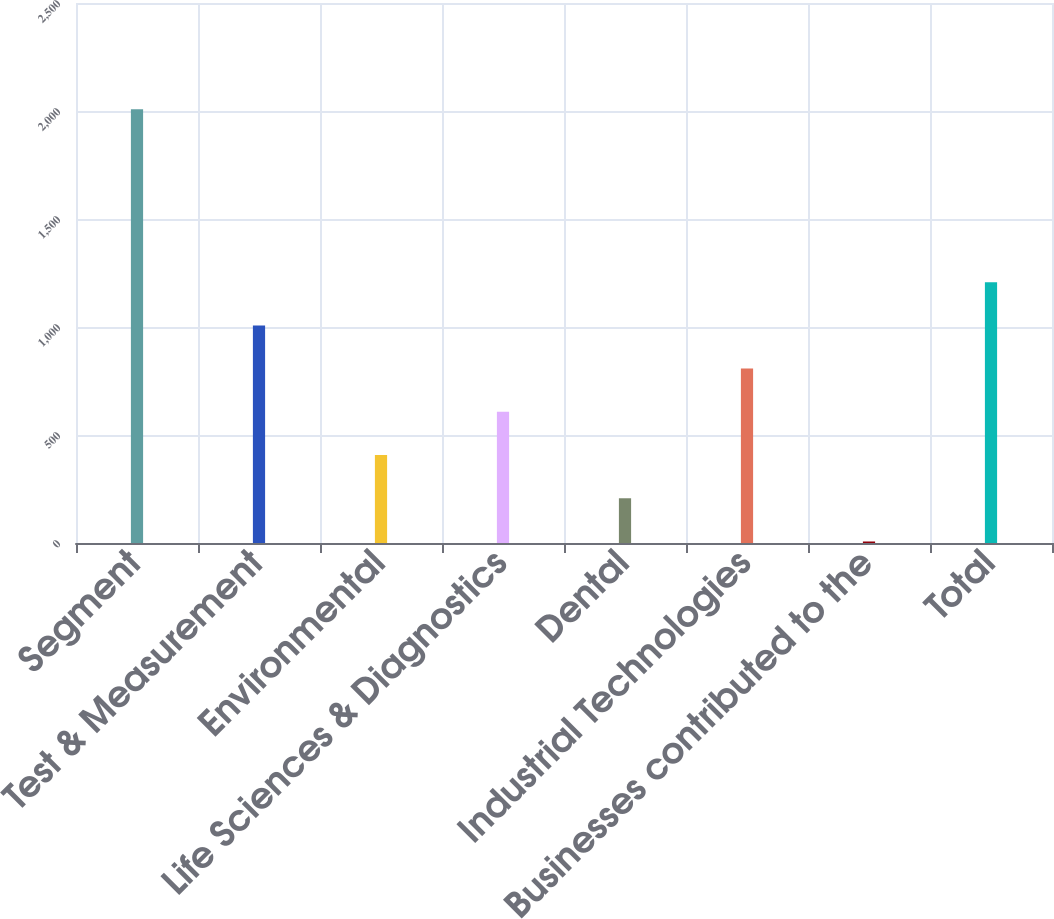Convert chart. <chart><loc_0><loc_0><loc_500><loc_500><bar_chart><fcel>Segment<fcel>Test & Measurement<fcel>Environmental<fcel>Life Sciences & Diagnostics<fcel>Dental<fcel>Industrial Technologies<fcel>Businesses contributed to the<fcel>Total<nl><fcel>2008<fcel>1007.5<fcel>407.2<fcel>607.3<fcel>207.1<fcel>807.4<fcel>7<fcel>1207.6<nl></chart> 